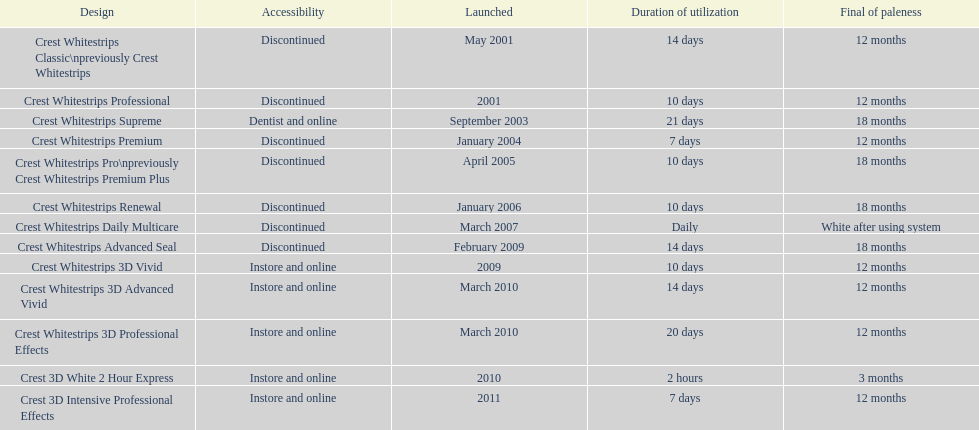What types of crest whitestrips have been released? Crest Whitestrips Classic\npreviously Crest Whitestrips, Crest Whitestrips Professional, Crest Whitestrips Supreme, Crest Whitestrips Premium, Crest Whitestrips Pro\npreviously Crest Whitestrips Premium Plus, Crest Whitestrips Renewal, Crest Whitestrips Daily Multicare, Crest Whitestrips Advanced Seal, Crest Whitestrips 3D Vivid, Crest Whitestrips 3D Advanced Vivid, Crest Whitestrips 3D Professional Effects, Crest 3D White 2 Hour Express, Crest 3D Intensive Professional Effects. What was the length of use for each type? 14 days, 10 days, 21 days, 7 days, 10 days, 10 days, Daily, 14 days, 10 days, 14 days, 20 days, 2 hours, 7 days. And how long did each last? 12 months, 12 months, 18 months, 12 months, 18 months, 18 months, White after using system, 18 months, 12 months, 12 months, 12 months, 3 months, 12 months. Of those models, which lasted the longest with the longest length of use? Crest Whitestrips Supreme. 